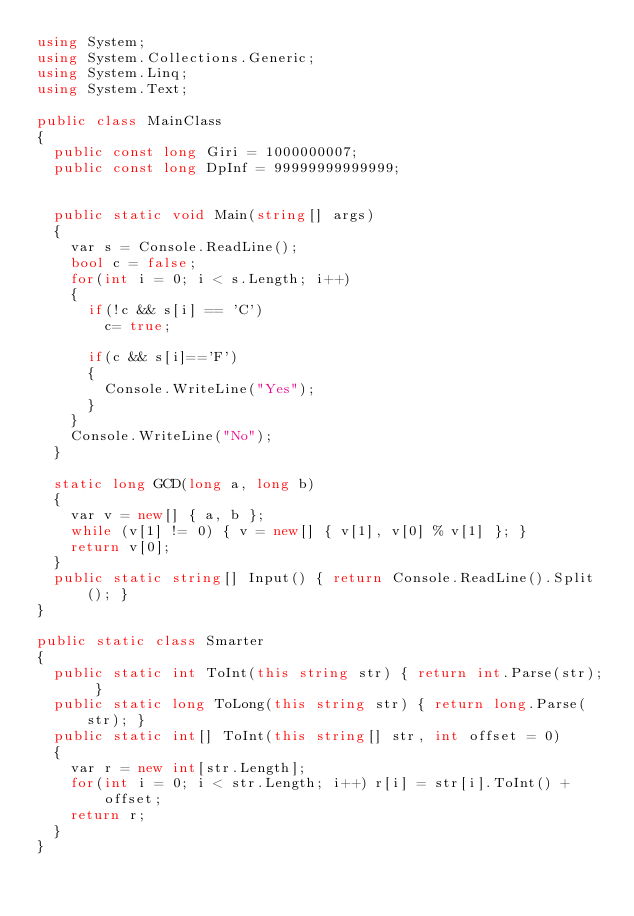Convert code to text. <code><loc_0><loc_0><loc_500><loc_500><_C#_>using System;
using System.Collections.Generic;
using System.Linq;
using System.Text;

public class MainClass
{
	public const long Giri = 1000000007;
	public const long DpInf = 99999999999999;

	
	public static void Main(string[] args)
	{
		var s = Console.ReadLine();
		bool c = false;
		for(int i = 0; i < s.Length; i++)
		{
			if(!c && s[i] == 'C')
				c= true;
			
			if(c && s[i]=='F')
			{
				Console.WriteLine("Yes");
			}
		}
		Console.WriteLine("No");
	}
	
	static long GCD(long a, long b)
	{
		var v = new[] { a, b };
		while (v[1] != 0) { v = new[] { v[1], v[0] % v[1] }; }
		return v[0];
	}
	public static string[] Input() { return Console.ReadLine().Split(); }
}

public static class Smarter
{
	public static int ToInt(this string str) { return int.Parse(str); }
	public static long ToLong(this string str) { return long.Parse(str); }
	public static int[] ToInt(this string[] str, int offset = 0)
	{
		var r = new int[str.Length];
		for(int i = 0; i < str.Length; i++) r[i] = str[i].ToInt() + offset;
		return r;
	}
}</code> 